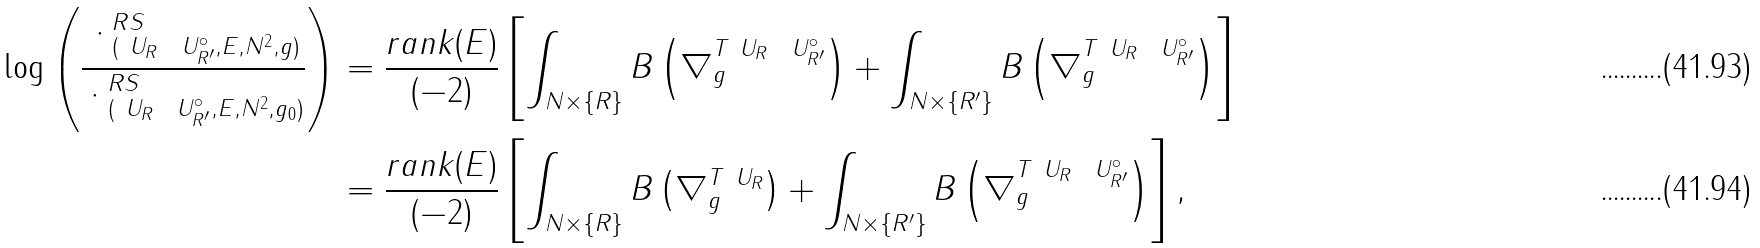Convert formula to latex. <formula><loc_0><loc_0><loc_500><loc_500>\log \left ( \frac { \| \cdot \| ^ { R S } _ { ( \ U _ { R } \ \ U ^ { \circ } _ { R ^ { \prime } } , E , N ^ { 2 } , g ) } } { \| \cdot \| ^ { R S } _ { ( \ U _ { R } \ \ U ^ { \circ } _ { R ^ { \prime } } , E , N ^ { 2 } , g _ { 0 } ) } } \right ) & = \frac { r a n k ( E ) } { ( - 2 ) } \left [ \int _ { N \times \{ R \} } B \left ( \nabla ^ { T \ U _ { R } \ \ U ^ { \circ } _ { R ^ { \prime } } } _ { g } \right ) + \int _ { N \times \{ R ^ { \prime } \} } B \left ( \nabla ^ { T \ U _ { R } \ \ U ^ { \circ } _ { R ^ { \prime } } } _ { g } \right ) \right ] \\ & = \frac { r a n k ( E ) } { ( - 2 ) } \left [ \int _ { N \times \{ R \} } B \left ( \nabla ^ { T \ U _ { R } } _ { g } \right ) + \int _ { N \times \{ R ^ { \prime } \} } B \left ( \nabla ^ { T \ U _ { R } \ \ U ^ { \circ } _ { R ^ { \prime } } } _ { g } \right ) \right ] ,</formula> 